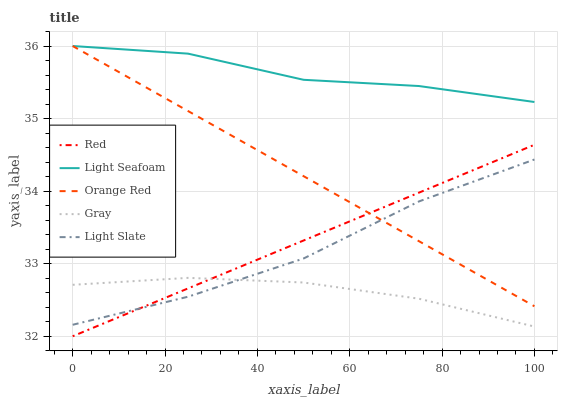Does Gray have the minimum area under the curve?
Answer yes or no. Yes. Does Light Seafoam have the maximum area under the curve?
Answer yes or no. Yes. Does Light Seafoam have the minimum area under the curve?
Answer yes or no. No. Does Gray have the maximum area under the curve?
Answer yes or no. No. Is Orange Red the smoothest?
Answer yes or no. Yes. Is Light Seafoam the roughest?
Answer yes or no. Yes. Is Gray the smoothest?
Answer yes or no. No. Is Gray the roughest?
Answer yes or no. No. Does Red have the lowest value?
Answer yes or no. Yes. Does Gray have the lowest value?
Answer yes or no. No. Does Orange Red have the highest value?
Answer yes or no. Yes. Does Gray have the highest value?
Answer yes or no. No. Is Light Slate less than Light Seafoam?
Answer yes or no. Yes. Is Light Seafoam greater than Light Slate?
Answer yes or no. Yes. Does Orange Red intersect Light Seafoam?
Answer yes or no. Yes. Is Orange Red less than Light Seafoam?
Answer yes or no. No. Is Orange Red greater than Light Seafoam?
Answer yes or no. No. Does Light Slate intersect Light Seafoam?
Answer yes or no. No. 